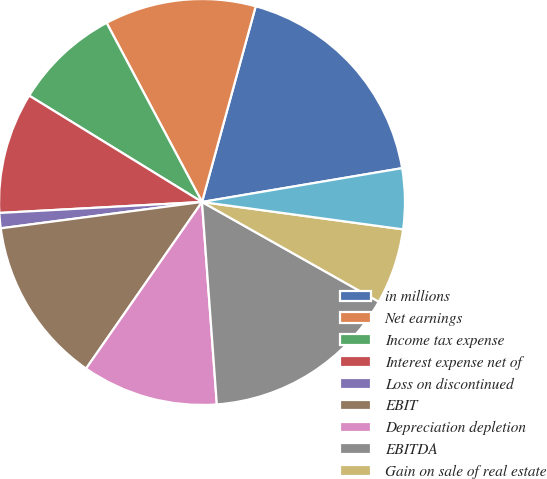Convert chart to OTSL. <chart><loc_0><loc_0><loc_500><loc_500><pie_chart><fcel>in millions<fcel>Net earnings<fcel>Income tax expense<fcel>Interest expense net of<fcel>Loss on discontinued<fcel>EBIT<fcel>Depreciation depletion<fcel>EBITDA<fcel>Gain on sale of real estate<fcel>Business interruption claims<nl><fcel>18.07%<fcel>12.05%<fcel>8.43%<fcel>9.64%<fcel>1.21%<fcel>13.25%<fcel>10.84%<fcel>15.66%<fcel>6.02%<fcel>4.82%<nl></chart> 